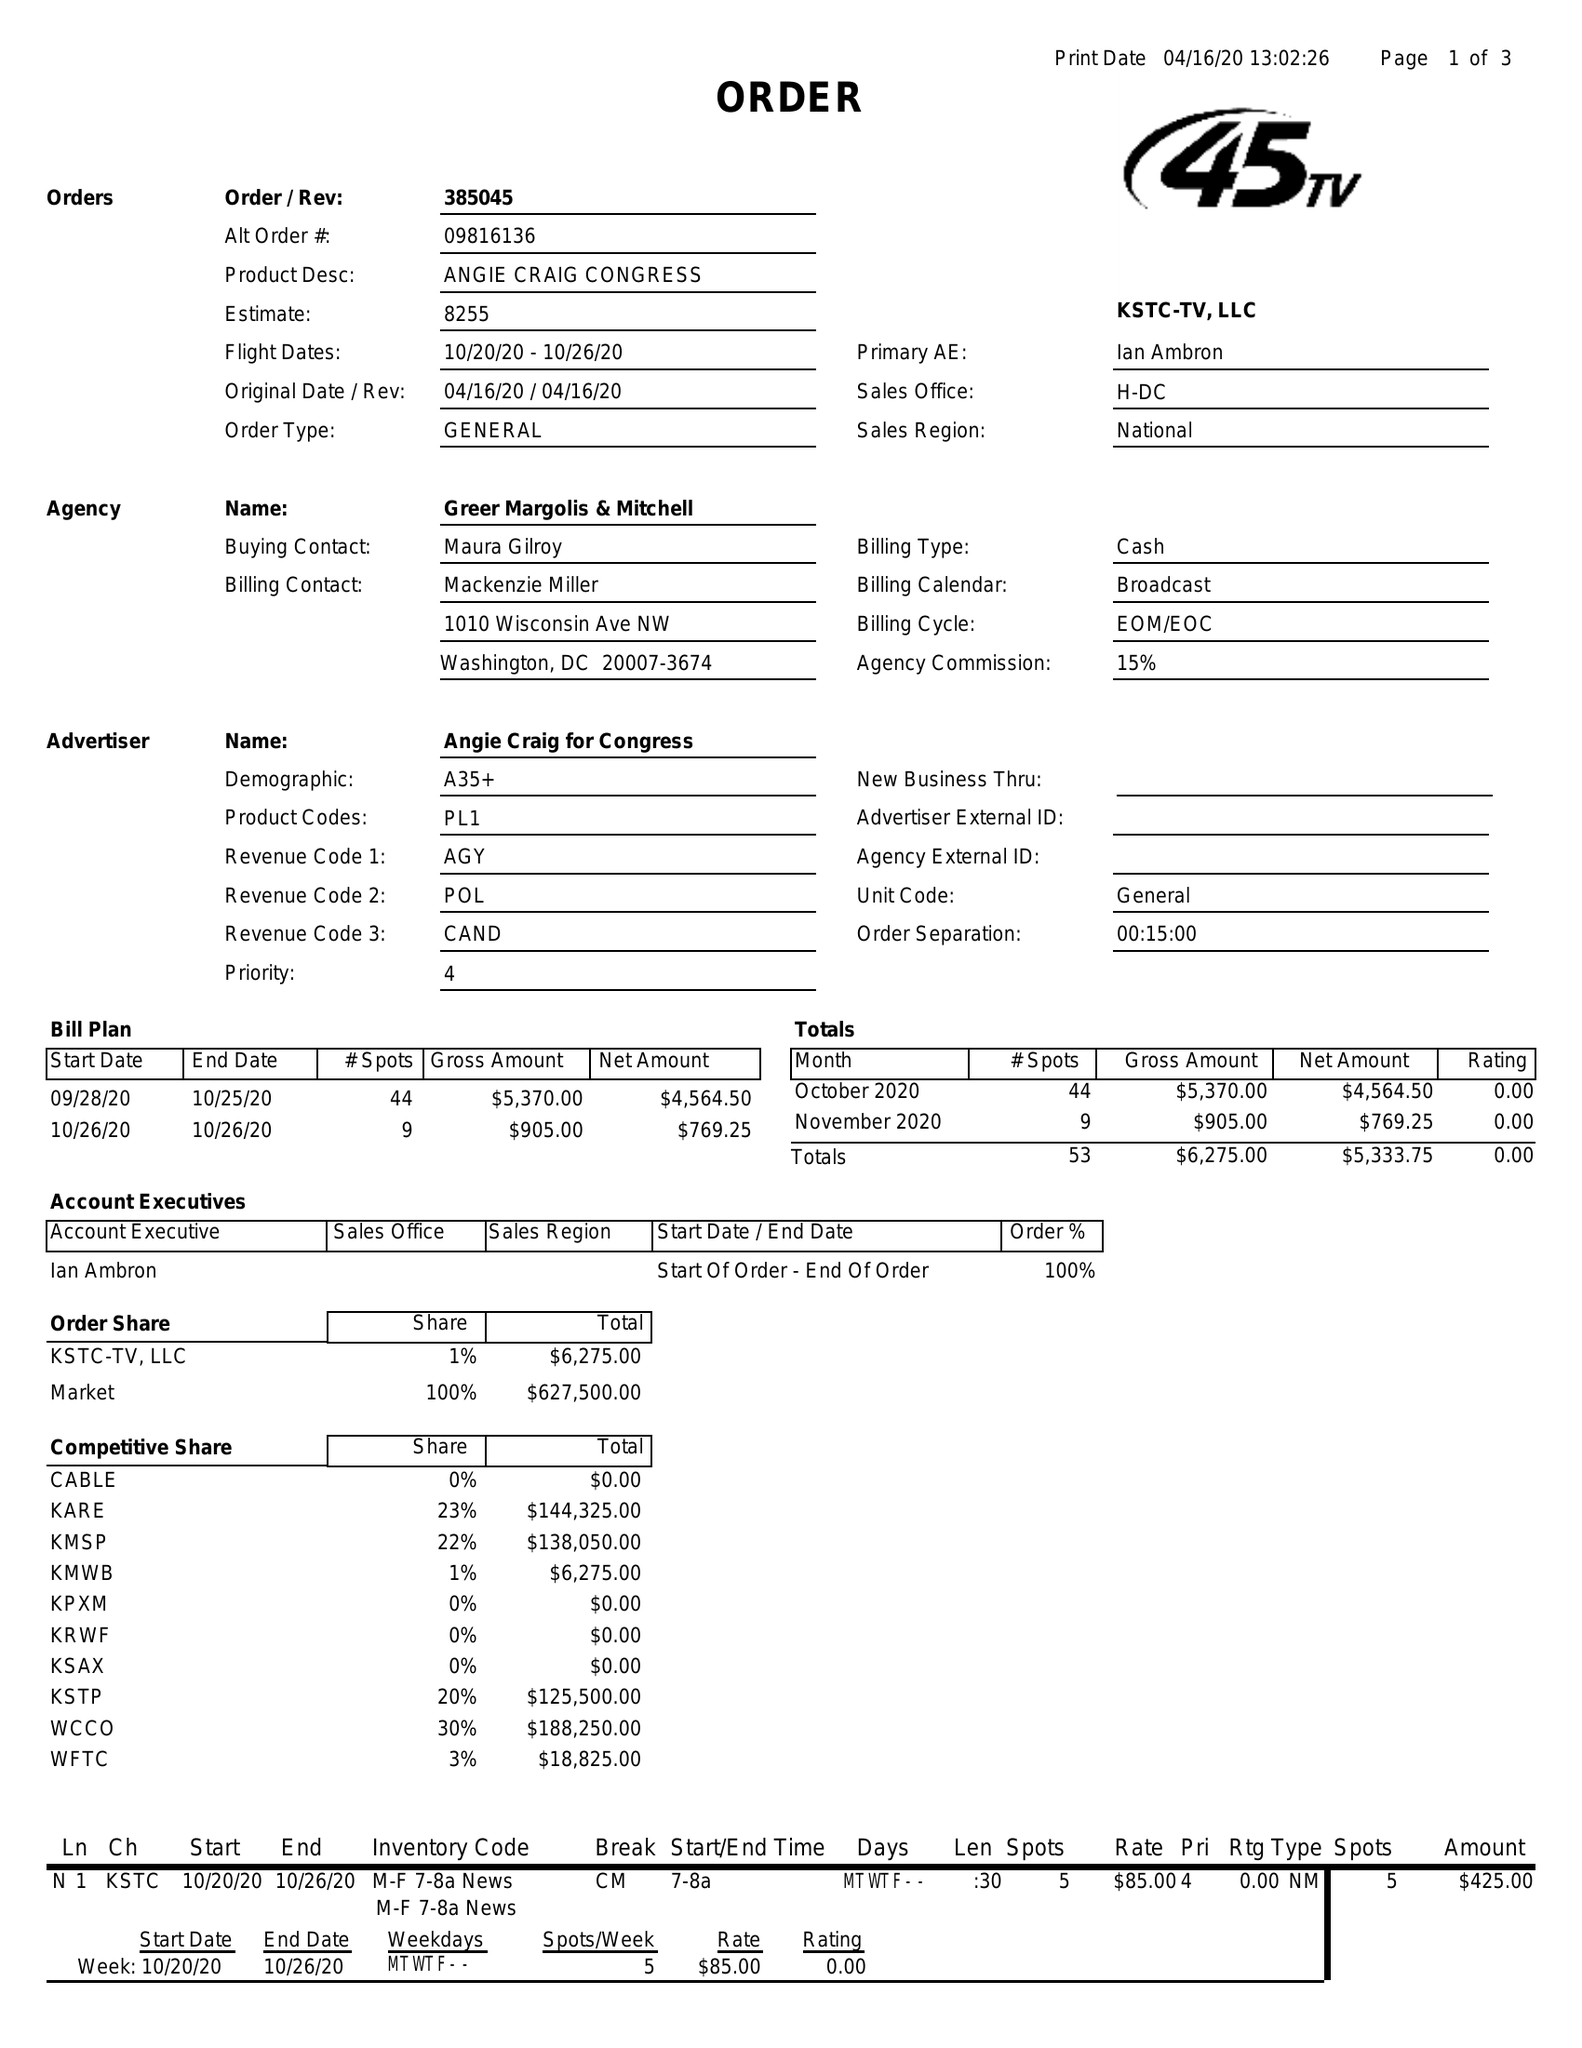What is the value for the gross_amount?
Answer the question using a single word or phrase. 6275.00 